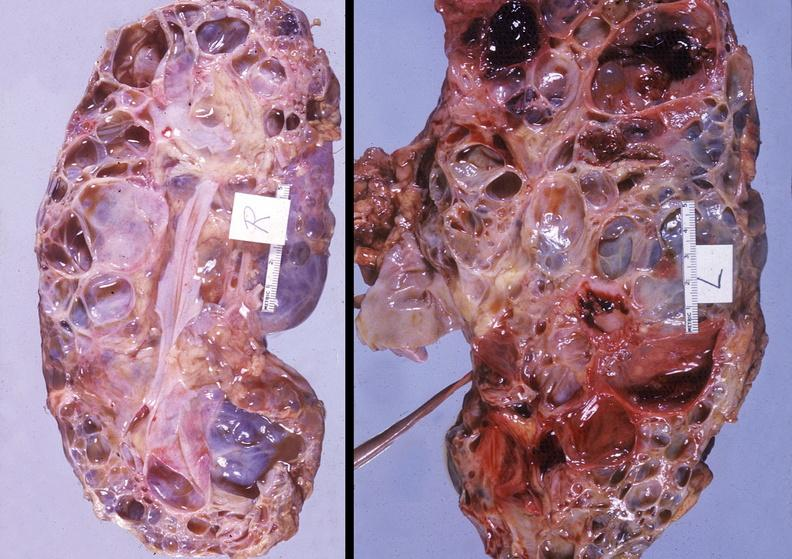what does this image show?
Answer the question using a single word or phrase. Kidney 